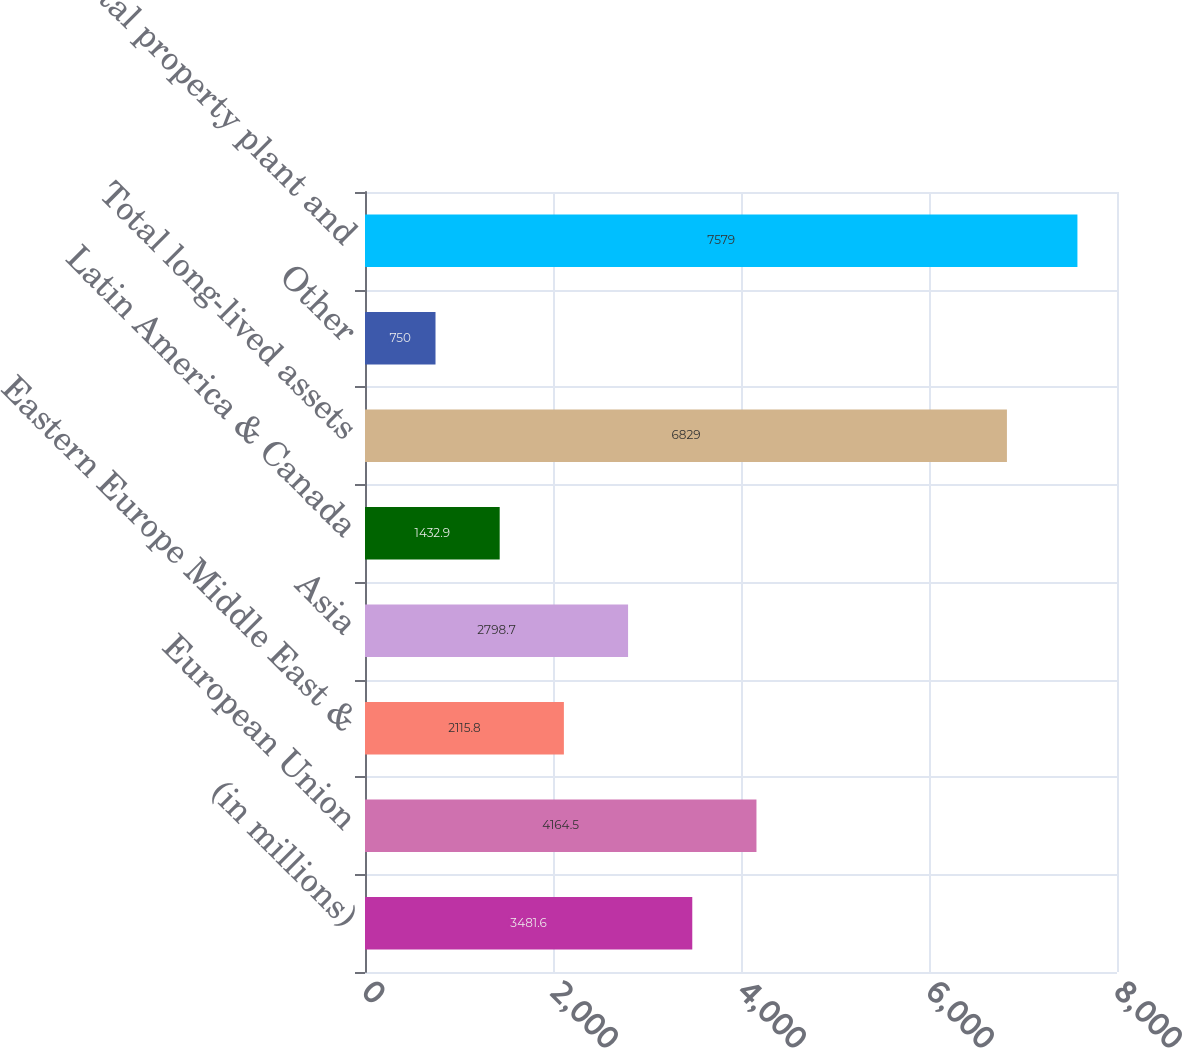<chart> <loc_0><loc_0><loc_500><loc_500><bar_chart><fcel>(in millions)<fcel>European Union<fcel>Eastern Europe Middle East &<fcel>Asia<fcel>Latin America & Canada<fcel>Total long-lived assets<fcel>Other<fcel>Total property plant and<nl><fcel>3481.6<fcel>4164.5<fcel>2115.8<fcel>2798.7<fcel>1432.9<fcel>6829<fcel>750<fcel>7579<nl></chart> 